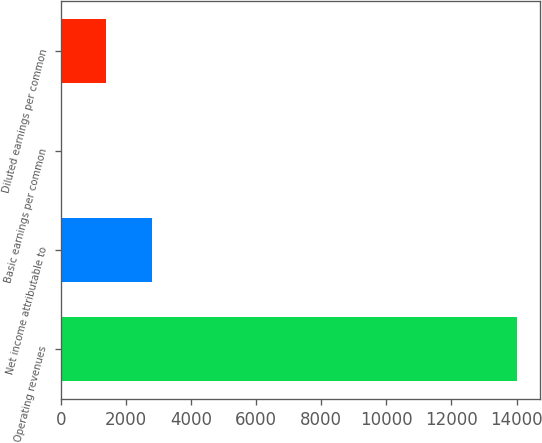Convert chart to OTSL. <chart><loc_0><loc_0><loc_500><loc_500><bar_chart><fcel>Operating revenues<fcel>Net income attributable to<fcel>Basic earnings per common<fcel>Diluted earnings per common<nl><fcel>14009<fcel>2803.19<fcel>1.73<fcel>1402.46<nl></chart> 